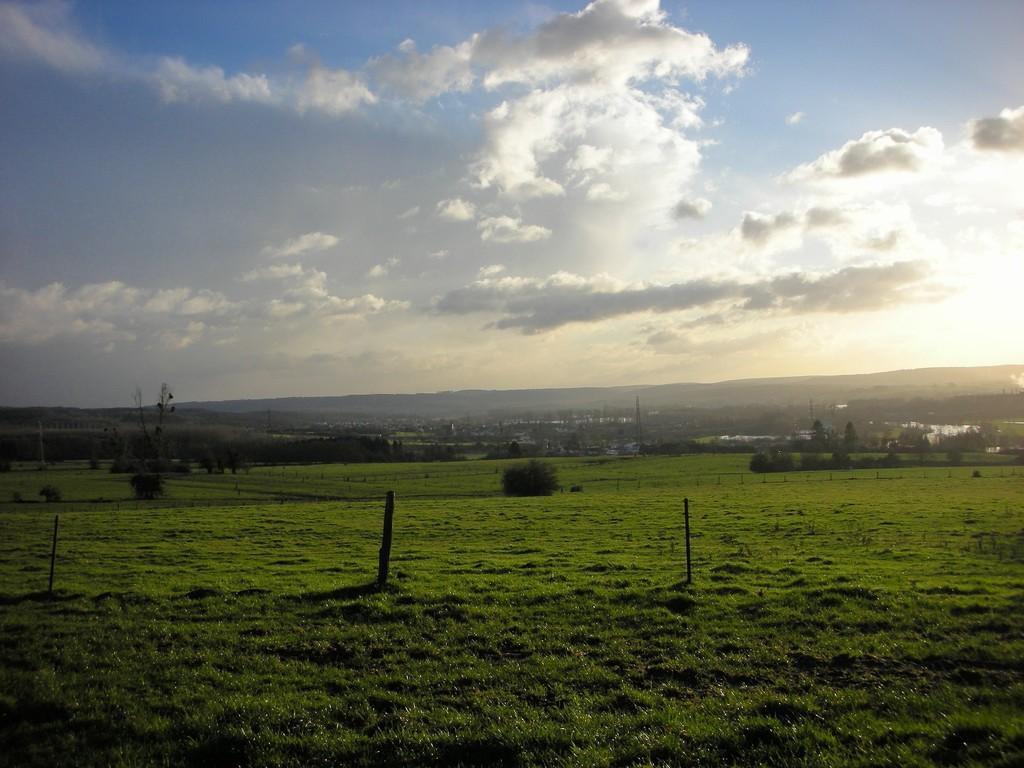Describe this image in one or two sentences. In this picture I can see many trees, plants, grass and farmland. On the right I can see the water. In the background I can see the mountains. At the top I can see the sky and clouds. In the top right I can see the sun's beam. 